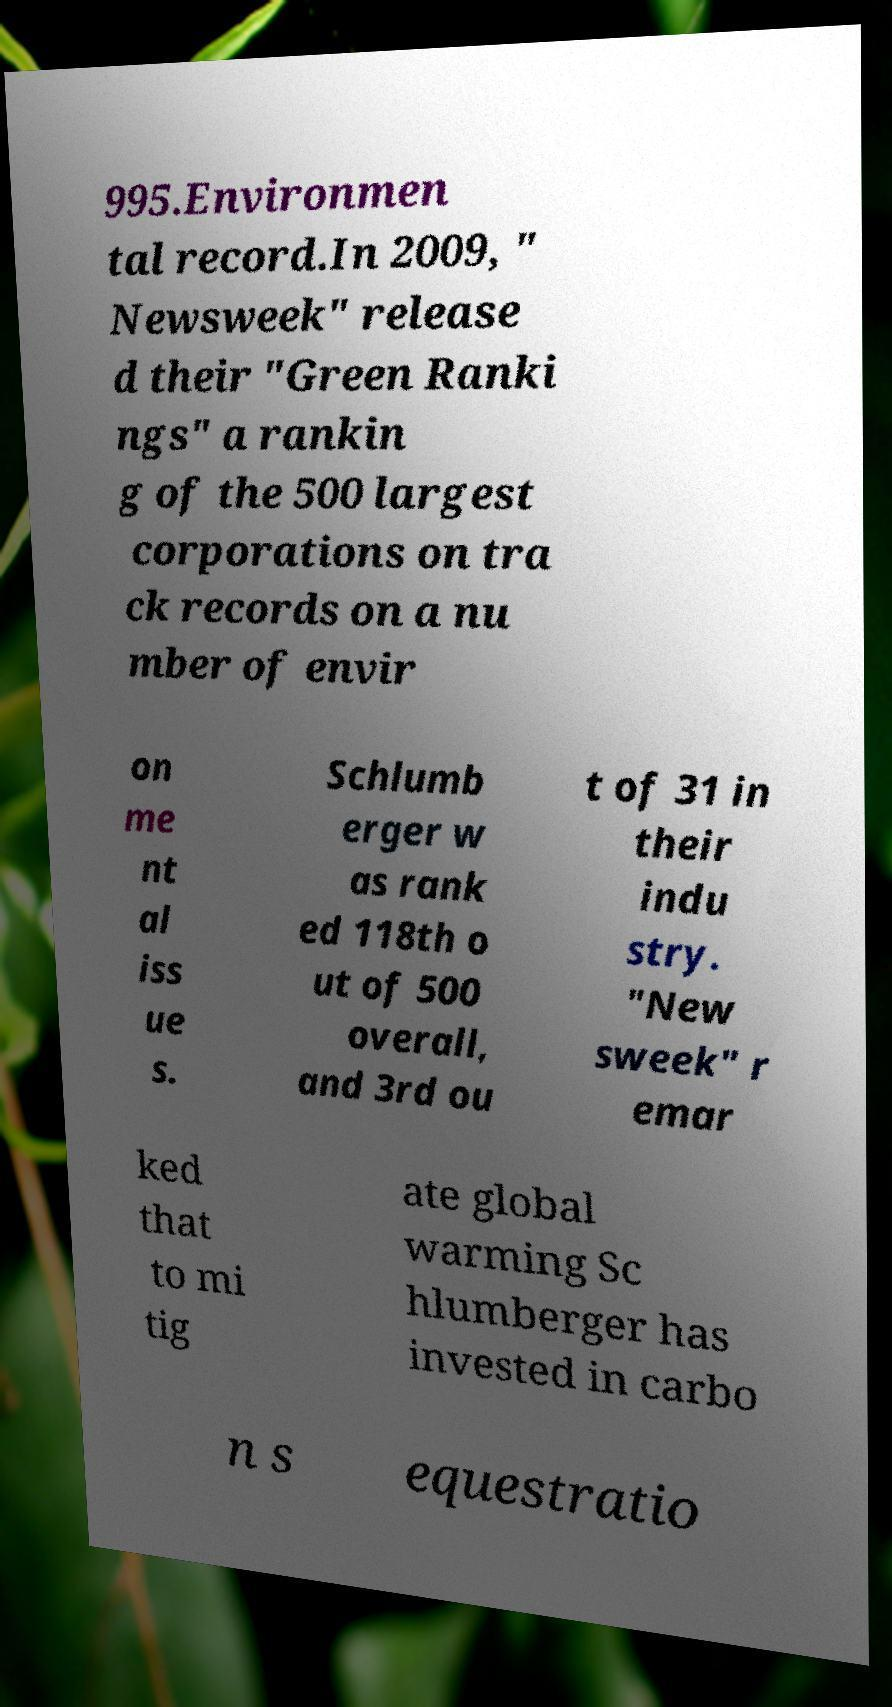Could you assist in decoding the text presented in this image and type it out clearly? 995.Environmen tal record.In 2009, " Newsweek" release d their "Green Ranki ngs" a rankin g of the 500 largest corporations on tra ck records on a nu mber of envir on me nt al iss ue s. Schlumb erger w as rank ed 118th o ut of 500 overall, and 3rd ou t of 31 in their indu stry. "New sweek" r emar ked that to mi tig ate global warming Sc hlumberger has invested in carbo n s equestratio 